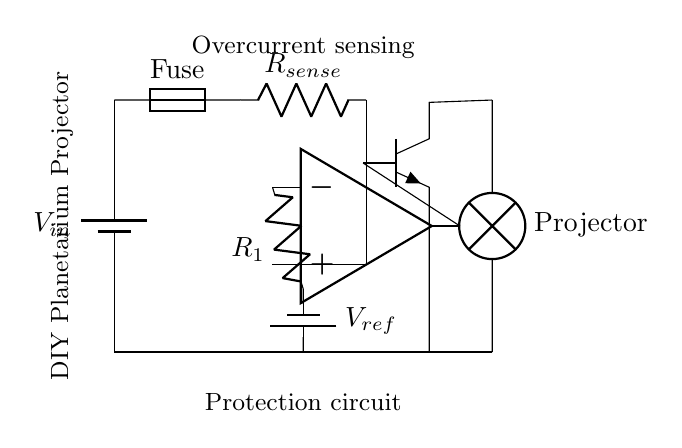What type of load is used in this circuit? The load in this circuit is indicated as a lamp, which represents the planetarium projector. It is shown connected to the output side of the circuit.
Answer: Projector What is the purpose of the fuse in this circuit? The fuse serves as a protective device that breaks the circuit in the event of an overcurrent, preventing damage to the circuit components, especially the projector.
Answer: Protection How many resistors are present in this circuit? There are two resistors depicted in the circuit: one is the current sensing resistor and the other is labeled as R1, which is associated with the op-amp.
Answer: Two What is the function of the op-amp in the circuit? The op-amp acts as a comparator, which compares the voltage across the current sensing resistor to a reference voltage, thereby determining if an overcurrent situation exists.
Answer: Comparator What voltage does the current sensing resistor measure? The current sensing resistor measures the voltage drop proportional to the current flowing through it. The value is not specified in the diagram, but it is related to the current.
Answer: Proportional to current What is the reference voltage needed for the op-amp? The op-amp requires a reference voltage to compare against the input from the sensing resistor. This voltage is indicated as V_ref and is provided by a battery.
Answer: V_ref What type of transistor is used in this circuit? The transistor used is an NPN type, which is common for switching applications in protection circuits like this one. Its role is to disconnect the load in the event of overcurrent.
Answer: NPN 